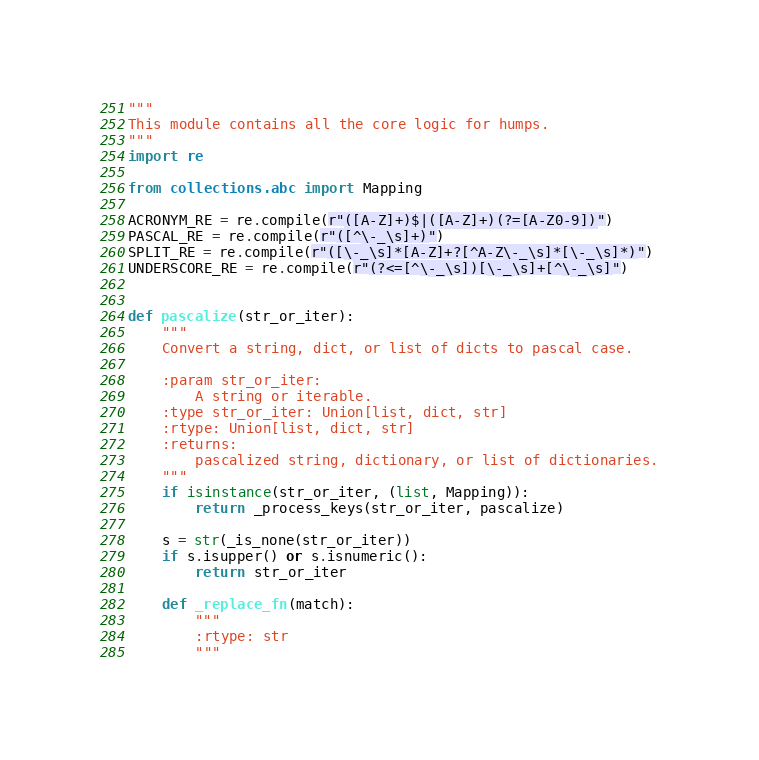<code> <loc_0><loc_0><loc_500><loc_500><_Python_>"""
This module contains all the core logic for humps.
"""
import re

from collections.abc import Mapping

ACRONYM_RE = re.compile(r"([A-Z]+)$|([A-Z]+)(?=[A-Z0-9])")
PASCAL_RE = re.compile(r"([^\-_\s]+)")
SPLIT_RE = re.compile(r"([\-_\s]*[A-Z]+?[^A-Z\-_\s]*[\-_\s]*)")
UNDERSCORE_RE = re.compile(r"(?<=[^\-_\s])[\-_\s]+[^\-_\s]")


def pascalize(str_or_iter):
    """
    Convert a string, dict, or list of dicts to pascal case.

    :param str_or_iter:
        A string or iterable.
    :type str_or_iter: Union[list, dict, str]
    :rtype: Union[list, dict, str]
    :returns:
        pascalized string, dictionary, or list of dictionaries.
    """
    if isinstance(str_or_iter, (list, Mapping)):
        return _process_keys(str_or_iter, pascalize)

    s = str(_is_none(str_or_iter))
    if s.isupper() or s.isnumeric():
        return str_or_iter

    def _replace_fn(match):
        """
        :rtype: str
        """</code> 